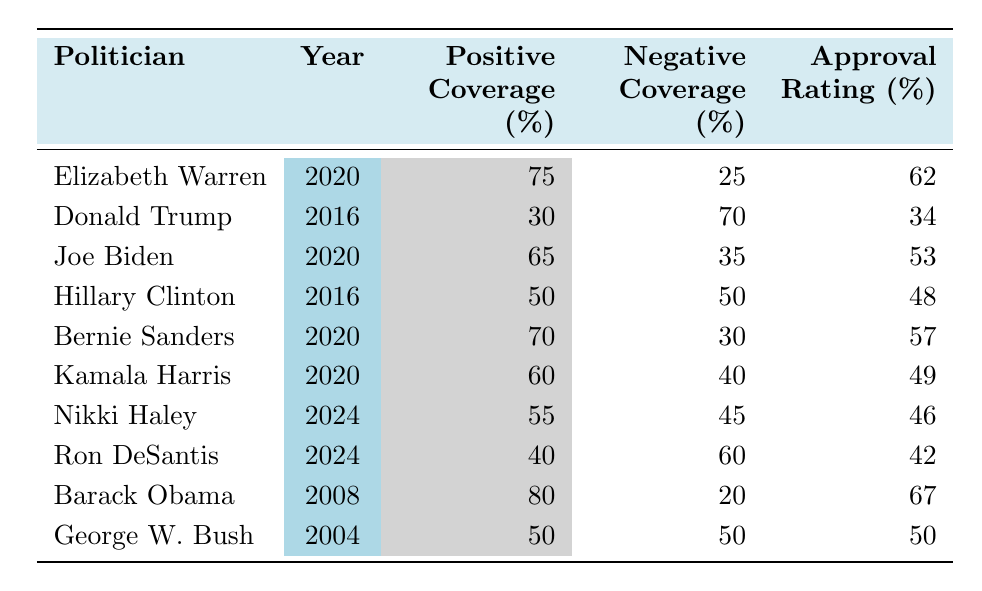What is the public approval rating for Elizabeth Warren in 2020? The table shows that Elizabeth Warren had a public approval rating of 62% in the year 2020.
Answer: 62% Which politician had the highest percentage of positive media coverage in their election year? According to the table, Barack Obama had the highest percentage of positive media coverage at 80% in 2008.
Answer: Barack Obama What was the difference in public approval ratings between Joe Biden and Hillary Clinton in 2016? Joe Biden's rating in 2020 is 53%, while Hillary Clinton's rating in 2016 is 48%. The difference is 53% - 48% = 5%.
Answer: 5% Did Ron DeSantis receive more negative media coverage than positive coverage in 2024? The table indicates that Ron DeSantis had 60% negative coverage compared to 40% positive coverage, which means he did receive more negative coverage.
Answer: Yes What is the average public approval rating across all politicians listed in 2020? The public approval ratings for politicians in 2020 are 62% (Warren), 53% (Biden), 57% (Sanders), and 49% (Harris). Their sum is 62 + 53 + 57 + 49 = 221, and there are 4 politicians, so the average is 221 / 4 = 55.25%.
Answer: 55.25% Which politician had the lowest public approval rating in their respective election year? The table shows that Donald Trump had the lowest public approval rating of 34% in 2016.
Answer: Donald Trump How much more negative coverage did Donald Trump receive compared to Barack Obama? Donald Trump had 70% negative coverage in 2016 and Barack Obama had 20% negative coverage in 2008. The difference is 70% - 20% = 50%.
Answer: 50% Is there a correlation between higher positive media coverage and higher public approval ratings in the table? Analyzing the table, it can be observed that as positive media coverage increases, public approval ratings tend to be higher, indicating a correlation.
Answer: Yes What was the total percentage of media coverage (positive and negative) for Kamala Harris in 2020? Kamala Harris had 60% positive and 40% negative media coverage, so the total is 60% + 40% = 100%.
Answer: 100% Which politician had a public approval rating closest to the median approval rating in the table? The public approval ratings are 34, 42, 46, 48, 49, 53, 55.25 (average), 57, 62, and 67. The median is (49 + 50)/2 = 49. The closest rating is 49% from Kamala Harris.
Answer: Kamala Harris If you combine the positive media coverage percentages for all politicians in 2024, what is the result? The positive media coverage for 2024 politicians (Nikki Haley and Ron DeSantis) is 55% + 40% = 95%.
Answer: 95% 